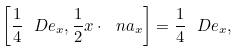Convert formula to latex. <formula><loc_0><loc_0><loc_500><loc_500>\left [ \frac { 1 } { 4 } \ D e _ { x } , \frac { 1 } { 2 } x \cdot \ n a _ { x } \right ] = \frac { 1 } { 4 } \ D e _ { x } ,</formula> 